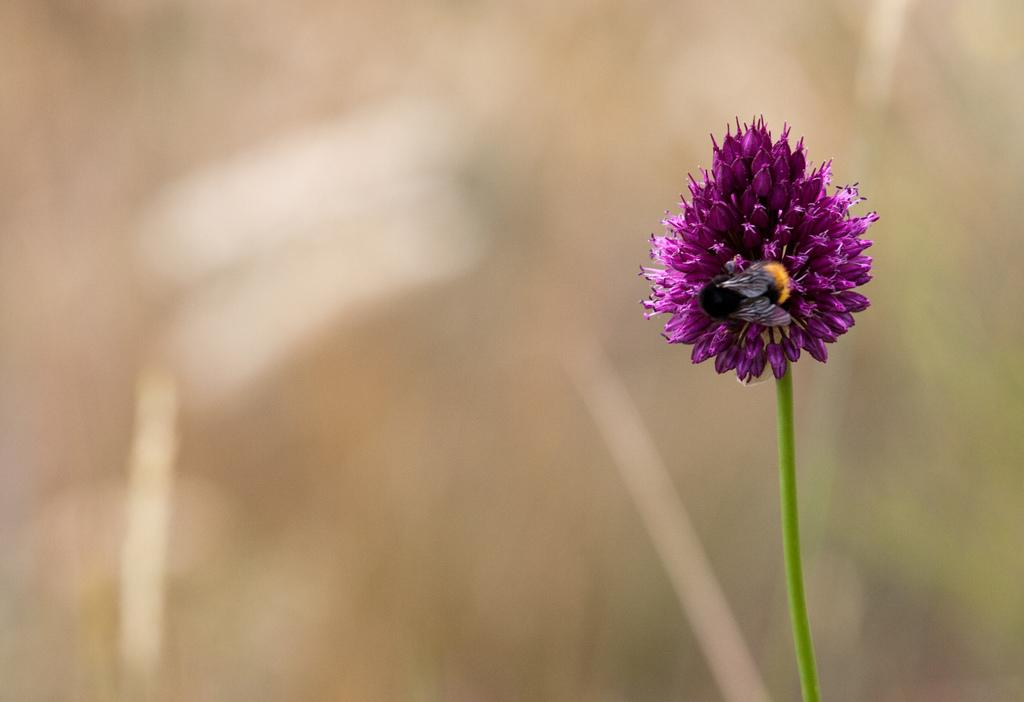What is the main subject of the image? The main subject of the image is a flower with a stem. Is there anything else on the flower in the image? Yes, there is an insect on the flower. How would you describe the background of the image? The background of the image is blurred. What type of glove is the secretary wearing in the image? There is no glove or secretary present in the image; it features a flower with a stem and an insect. 